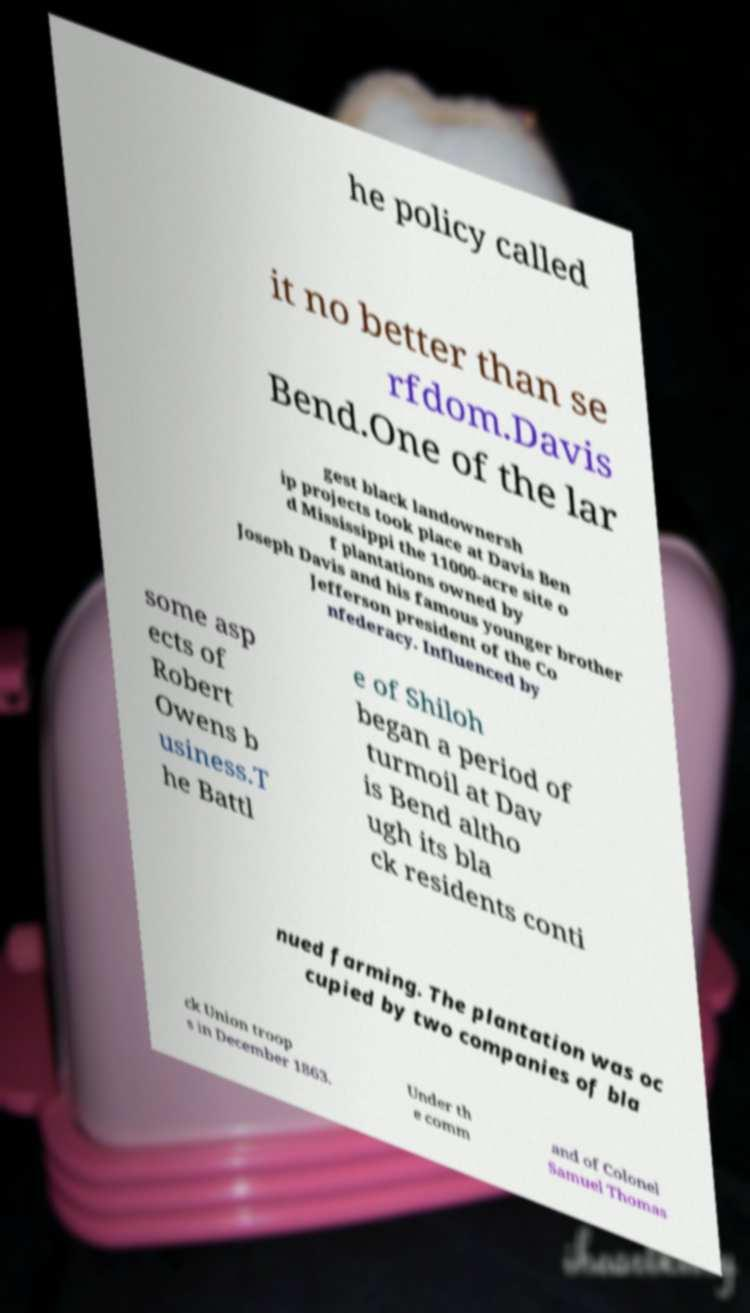Please read and relay the text visible in this image. What does it say? he policy called it no better than se rfdom.Davis Bend.One of the lar gest black landownersh ip projects took place at Davis Ben d Mississippi the 11000-acre site o f plantations owned by Joseph Davis and his famous younger brother Jefferson president of the Co nfederacy. Influenced by some asp ects of Robert Owens b usiness.T he Battl e of Shiloh began a period of turmoil at Dav is Bend altho ugh its bla ck residents conti nued farming. The plantation was oc cupied by two companies of bla ck Union troop s in December 1863. Under th e comm and of Colonel Samuel Thomas 